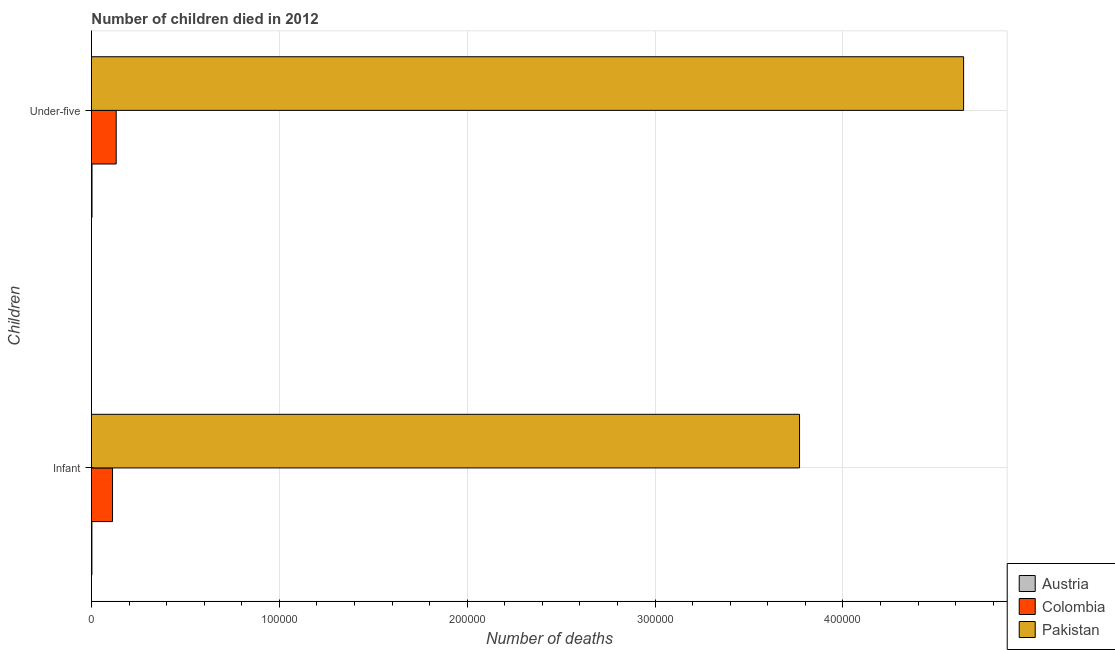How many groups of bars are there?
Provide a succinct answer. 2. Are the number of bars per tick equal to the number of legend labels?
Your response must be concise. Yes. Are the number of bars on each tick of the Y-axis equal?
Your answer should be compact. Yes. How many bars are there on the 2nd tick from the top?
Make the answer very short. 3. How many bars are there on the 2nd tick from the bottom?
Ensure brevity in your answer.  3. What is the label of the 2nd group of bars from the top?
Give a very brief answer. Infant. What is the number of infant deaths in Colombia?
Your response must be concise. 1.12e+04. Across all countries, what is the maximum number of infant deaths?
Make the answer very short. 3.77e+05. Across all countries, what is the minimum number of under-five deaths?
Give a very brief answer. 315. In which country was the number of infant deaths maximum?
Your answer should be compact. Pakistan. In which country was the number of infant deaths minimum?
Your response must be concise. Austria. What is the total number of infant deaths in the graph?
Keep it short and to the point. 3.88e+05. What is the difference between the number of infant deaths in Austria and that in Pakistan?
Provide a short and direct response. -3.77e+05. What is the difference between the number of infant deaths in Pakistan and the number of under-five deaths in Austria?
Your answer should be very brief. 3.77e+05. What is the average number of infant deaths per country?
Your answer should be very brief. 1.29e+05. What is the difference between the number of infant deaths and number of under-five deaths in Pakistan?
Your answer should be compact. -8.73e+04. What is the ratio of the number of infant deaths in Colombia to that in Austria?
Your answer should be compact. 43.2. What does the 3rd bar from the top in Under-five represents?
Give a very brief answer. Austria. What does the 1st bar from the bottom in Infant represents?
Make the answer very short. Austria. How many bars are there?
Provide a succinct answer. 6. Are all the bars in the graph horizontal?
Your answer should be very brief. Yes. How many countries are there in the graph?
Keep it short and to the point. 3. What is the title of the graph?
Offer a terse response. Number of children died in 2012. Does "Chile" appear as one of the legend labels in the graph?
Offer a terse response. No. What is the label or title of the X-axis?
Provide a short and direct response. Number of deaths. What is the label or title of the Y-axis?
Provide a short and direct response. Children. What is the Number of deaths of Austria in Infant?
Your answer should be compact. 260. What is the Number of deaths of Colombia in Infant?
Make the answer very short. 1.12e+04. What is the Number of deaths of Pakistan in Infant?
Ensure brevity in your answer.  3.77e+05. What is the Number of deaths of Austria in Under-five?
Keep it short and to the point. 315. What is the Number of deaths in Colombia in Under-five?
Ensure brevity in your answer.  1.32e+04. What is the Number of deaths of Pakistan in Under-five?
Your response must be concise. 4.64e+05. Across all Children, what is the maximum Number of deaths in Austria?
Provide a short and direct response. 315. Across all Children, what is the maximum Number of deaths in Colombia?
Keep it short and to the point. 1.32e+04. Across all Children, what is the maximum Number of deaths of Pakistan?
Provide a short and direct response. 4.64e+05. Across all Children, what is the minimum Number of deaths of Austria?
Ensure brevity in your answer.  260. Across all Children, what is the minimum Number of deaths of Colombia?
Your answer should be very brief. 1.12e+04. Across all Children, what is the minimum Number of deaths in Pakistan?
Offer a terse response. 3.77e+05. What is the total Number of deaths in Austria in the graph?
Give a very brief answer. 575. What is the total Number of deaths of Colombia in the graph?
Provide a short and direct response. 2.44e+04. What is the total Number of deaths of Pakistan in the graph?
Keep it short and to the point. 8.41e+05. What is the difference between the Number of deaths in Austria in Infant and that in Under-five?
Your answer should be very brief. -55. What is the difference between the Number of deaths of Colombia in Infant and that in Under-five?
Make the answer very short. -1958. What is the difference between the Number of deaths in Pakistan in Infant and that in Under-five?
Offer a very short reply. -8.73e+04. What is the difference between the Number of deaths of Austria in Infant and the Number of deaths of Colombia in Under-five?
Your answer should be very brief. -1.29e+04. What is the difference between the Number of deaths in Austria in Infant and the Number of deaths in Pakistan in Under-five?
Your answer should be very brief. -4.64e+05. What is the difference between the Number of deaths in Colombia in Infant and the Number of deaths in Pakistan in Under-five?
Your answer should be very brief. -4.53e+05. What is the average Number of deaths of Austria per Children?
Provide a succinct answer. 287.5. What is the average Number of deaths in Colombia per Children?
Your answer should be compact. 1.22e+04. What is the average Number of deaths of Pakistan per Children?
Ensure brevity in your answer.  4.21e+05. What is the difference between the Number of deaths in Austria and Number of deaths in Colombia in Infant?
Keep it short and to the point. -1.10e+04. What is the difference between the Number of deaths in Austria and Number of deaths in Pakistan in Infant?
Your answer should be compact. -3.77e+05. What is the difference between the Number of deaths of Colombia and Number of deaths of Pakistan in Infant?
Provide a succinct answer. -3.66e+05. What is the difference between the Number of deaths in Austria and Number of deaths in Colombia in Under-five?
Provide a succinct answer. -1.29e+04. What is the difference between the Number of deaths in Austria and Number of deaths in Pakistan in Under-five?
Your answer should be compact. -4.64e+05. What is the difference between the Number of deaths of Colombia and Number of deaths of Pakistan in Under-five?
Provide a succinct answer. -4.51e+05. What is the ratio of the Number of deaths in Austria in Infant to that in Under-five?
Keep it short and to the point. 0.83. What is the ratio of the Number of deaths of Colombia in Infant to that in Under-five?
Offer a terse response. 0.85. What is the ratio of the Number of deaths in Pakistan in Infant to that in Under-five?
Keep it short and to the point. 0.81. What is the difference between the highest and the second highest Number of deaths in Colombia?
Provide a succinct answer. 1958. What is the difference between the highest and the second highest Number of deaths in Pakistan?
Ensure brevity in your answer.  8.73e+04. What is the difference between the highest and the lowest Number of deaths in Austria?
Provide a succinct answer. 55. What is the difference between the highest and the lowest Number of deaths of Colombia?
Your answer should be compact. 1958. What is the difference between the highest and the lowest Number of deaths of Pakistan?
Make the answer very short. 8.73e+04. 